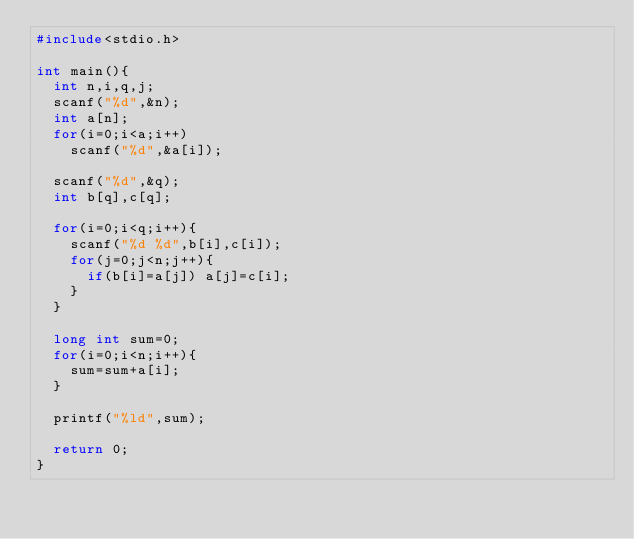<code> <loc_0><loc_0><loc_500><loc_500><_C_>#include<stdio.h>

int main(){
  int n,i,q,j;
  scanf("%d",&n);
  int a[n];
  for(i=0;i<a;i++)
    scanf("%d",&a[i]);
  
  scanf("%d",&q);
  int b[q],c[q];
  
  for(i=0;i<q;i++){
    scanf("%d %d",b[i],c[i]);
    for(j=0;j<n;j++){
      if(b[i]=a[j]) a[j]=c[i];
    }
  }
  
  long int sum=0;
  for(i=0;i<n;i++){
    sum=sum+a[i];
  }
  
  printf("%ld",sum);
  
  return 0;
}</code> 